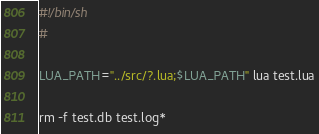Convert code to text. <code><loc_0><loc_0><loc_500><loc_500><_Bash_>#!/bin/sh
#

LUA_PATH="../src/?.lua;$LUA_PATH" lua test.lua

rm -f test.db test.log*

</code> 